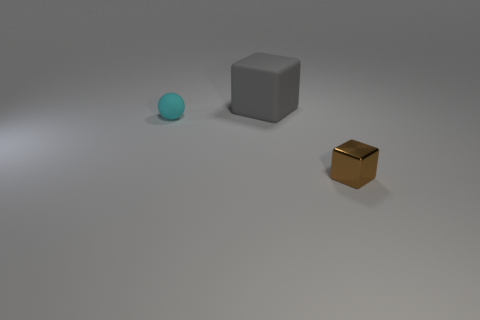Do the block that is left of the tiny brown block and the cyan object have the same material?
Your response must be concise. Yes. What number of yellow balls are there?
Ensure brevity in your answer.  0. How many objects are either cyan matte balls or brown objects?
Provide a succinct answer. 2. There is a block behind the tiny object that is left of the brown shiny thing; how many small objects are to the left of it?
Your answer should be compact. 1. Is there anything else that is the same color as the sphere?
Ensure brevity in your answer.  No. Does the small thing that is left of the small metallic thing have the same color as the block behind the small brown metal object?
Provide a short and direct response. No. Are there more big rubber objects to the right of the brown metallic object than gray matte cubes that are right of the large gray object?
Provide a short and direct response. No. What is the brown thing made of?
Provide a short and direct response. Metal. What is the shape of the tiny thing to the left of the block that is behind the tiny object to the left of the gray block?
Keep it short and to the point. Sphere. How many other objects are there of the same material as the gray thing?
Provide a short and direct response. 1. 